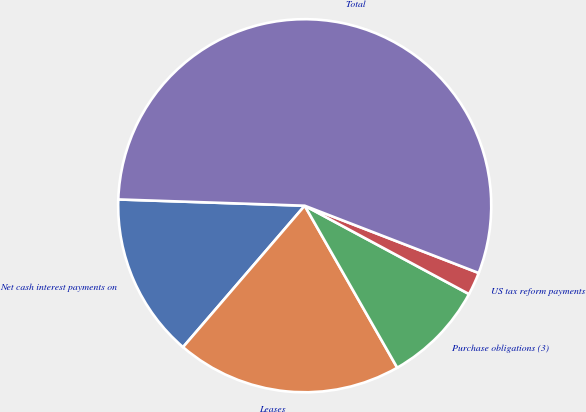Convert chart. <chart><loc_0><loc_0><loc_500><loc_500><pie_chart><fcel>Net cash interest payments on<fcel>Leases<fcel>Purchase obligations (3)<fcel>US tax reform payments<fcel>Total<nl><fcel>14.23%<fcel>19.57%<fcel>8.89%<fcel>1.98%<fcel>55.34%<nl></chart> 